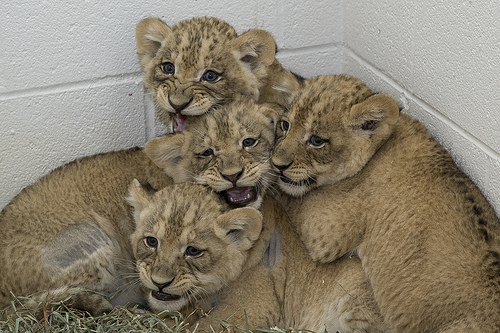<image>
Is the cub to the left of the cub? Yes. From this viewpoint, the cub is positioned to the left side relative to the cub. 